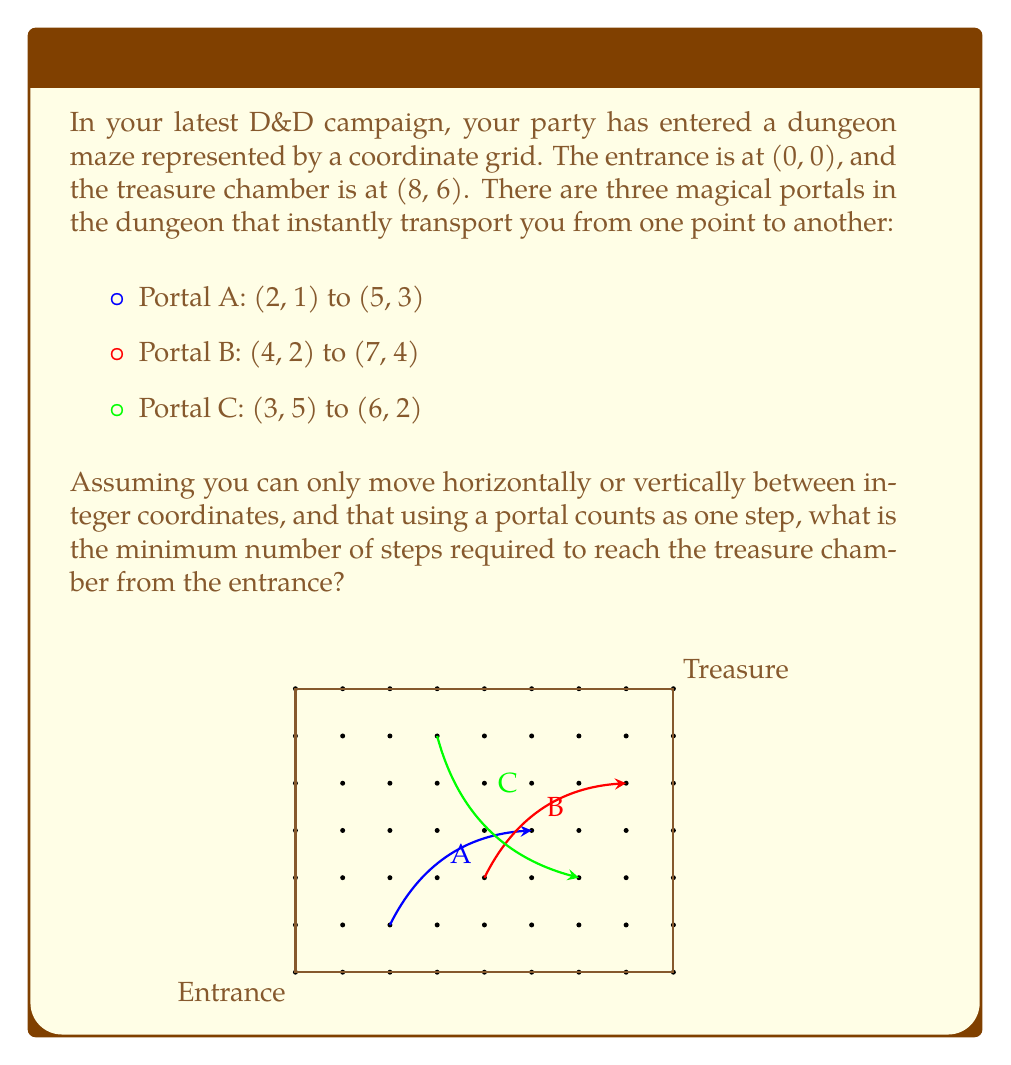Provide a solution to this math problem. Let's approach this step-by-step:

1) First, let's consider the Manhattan distance (sum of horizontal and vertical moves) without portals:
   $$(8-0) + (6-0) = 14$$ steps

2) Now, let's examine each portal:

   Portal A: (2, 1) to (5, 3)
   - Steps to reach: 2 + 1 = 3
   - Steps saved: (5-2) + (3-1) - 1 = 4

   Portal B: (4, 2) to (7, 4)
   - Steps to reach: 4 + 2 = 6
   - Steps saved: (7-4) + (4-2) - 1 = 4

   Portal C: (3, 5) to (6, 2)
   - Steps to reach: 3 + 5 = 8
   - Steps saved: (6-3) + (5-2) - 1 = 5

3) Portal C saves the most steps, but it's out of the way. Let's consider combining portals:

   Using A then B:
   - Steps: 3 (to A) + 1 (A) + 2 (A to B) + 1 (B) + 3 (B to treasure) = 10

   This is the most efficient path.

4) The path would be:
   (0,0) → (2,1) → A → (5,3) → (4,2) → B → (7,4) → (8,6)

Therefore, the minimum number of steps required is 10.
Answer: 10 steps 